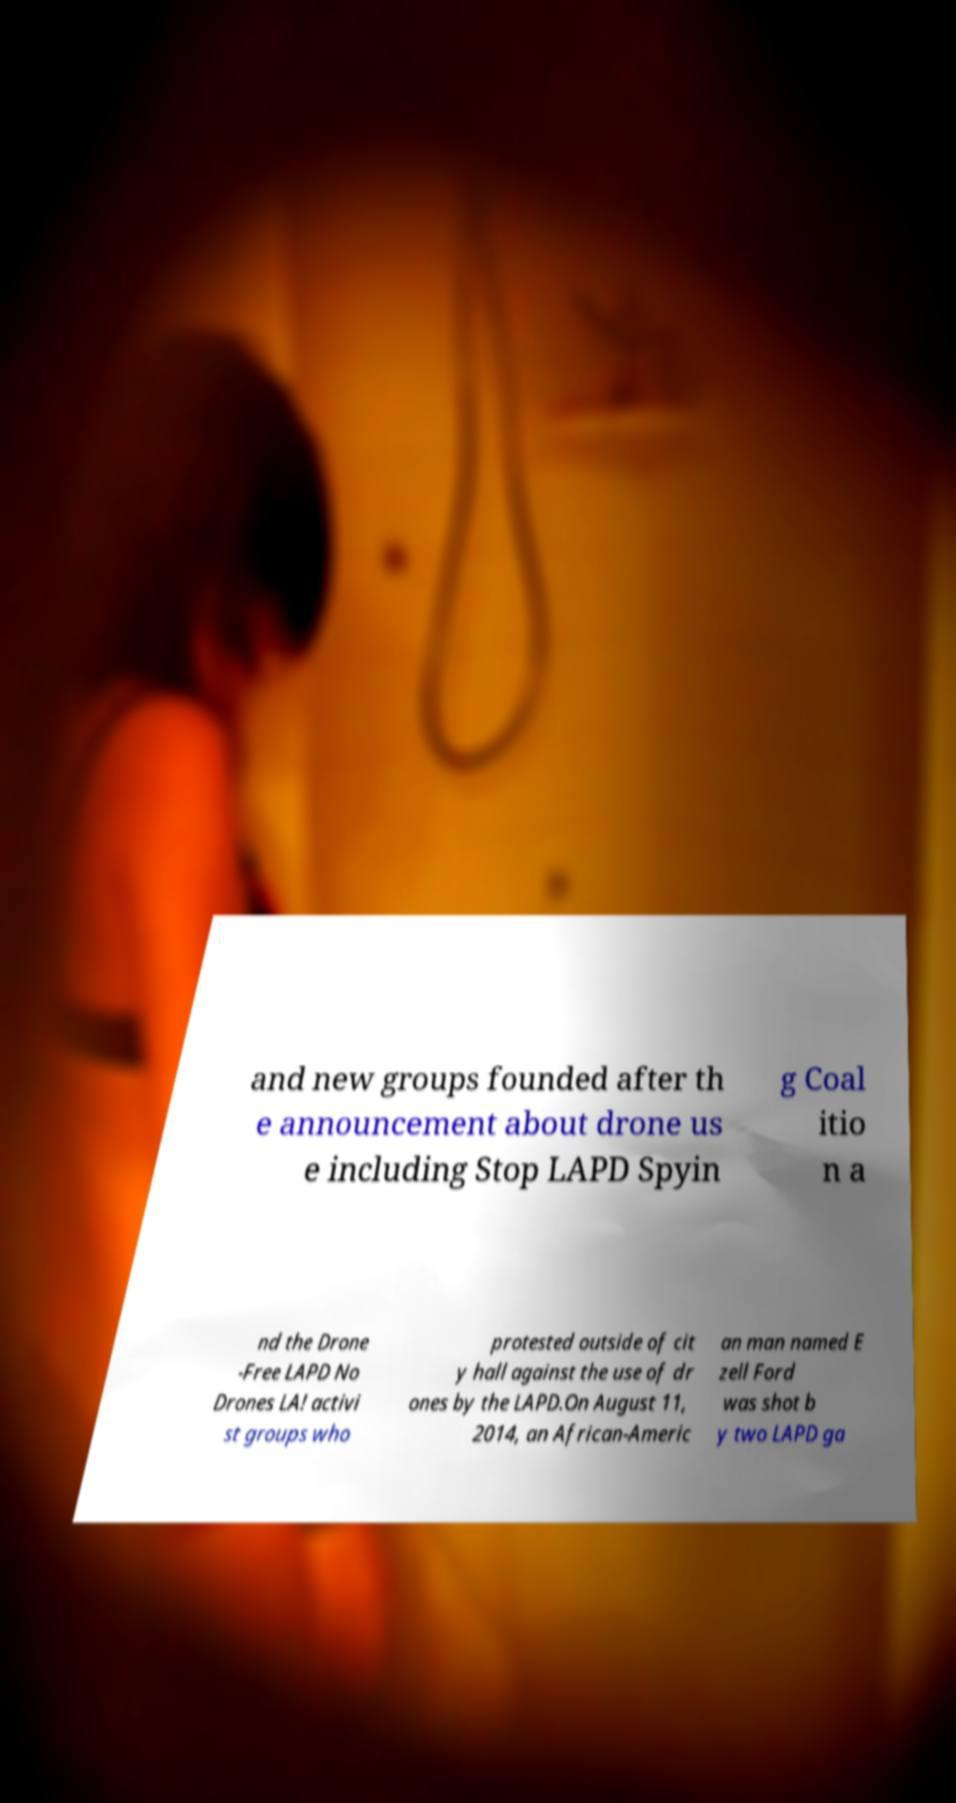Could you assist in decoding the text presented in this image and type it out clearly? and new groups founded after th e announcement about drone us e including Stop LAPD Spyin g Coal itio n a nd the Drone -Free LAPD No Drones LA! activi st groups who protested outside of cit y hall against the use of dr ones by the LAPD.On August 11, 2014, an African-Americ an man named E zell Ford was shot b y two LAPD ga 